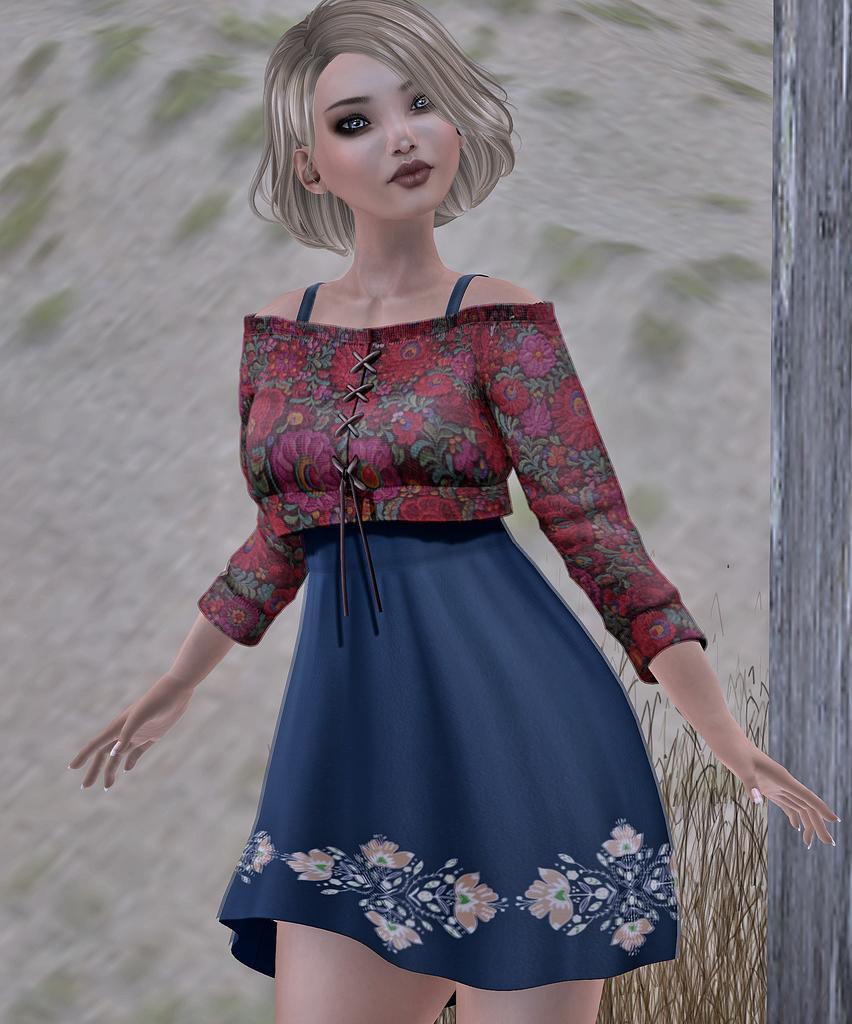Describe this image in one or two sentences. This image is a graphic. In the center of the image there is a woman. On the right side of the image we can see grass and tree. 